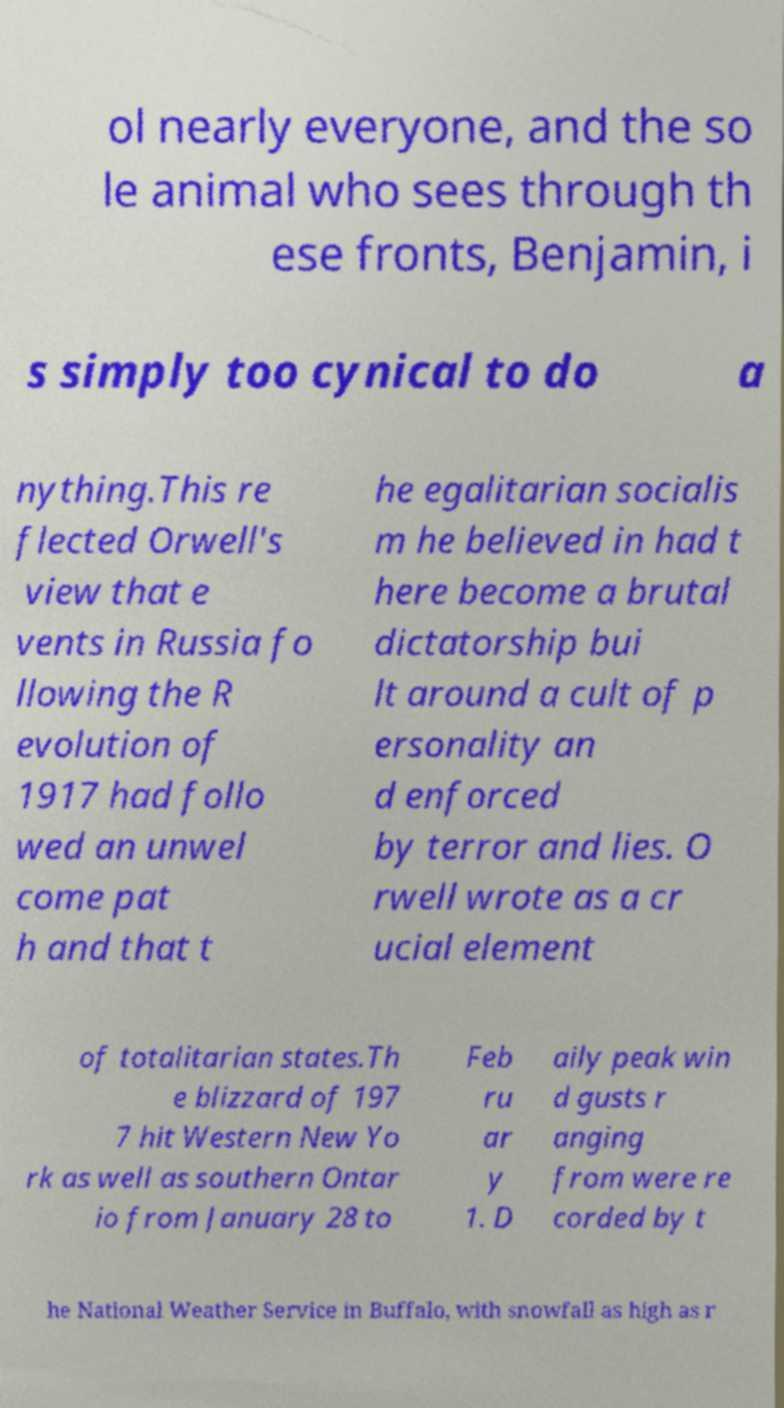Could you extract and type out the text from this image? ol nearly everyone, and the so le animal who sees through th ese fronts, Benjamin, i s simply too cynical to do a nything.This re flected Orwell's view that e vents in Russia fo llowing the R evolution of 1917 had follo wed an unwel come pat h and that t he egalitarian socialis m he believed in had t here become a brutal dictatorship bui lt around a cult of p ersonality an d enforced by terror and lies. O rwell wrote as a cr ucial element of totalitarian states.Th e blizzard of 197 7 hit Western New Yo rk as well as southern Ontar io from January 28 to Feb ru ar y 1. D aily peak win d gusts r anging from were re corded by t he National Weather Service in Buffalo, with snowfall as high as r 